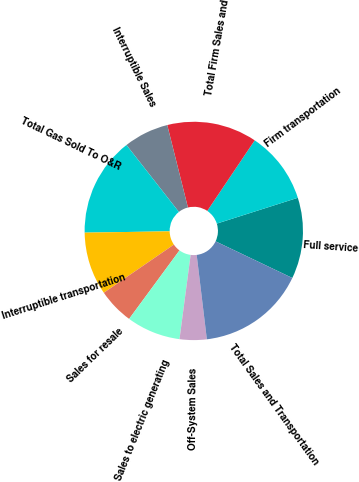<chart> <loc_0><loc_0><loc_500><loc_500><pie_chart><fcel>Full service<fcel>Firm transportation<fcel>Total Firm Sales and<fcel>Interruptible Sales<fcel>Total Gas Sold To O&R<fcel>Interruptible transportation<fcel>Sales for resale<fcel>Sales to electric generating<fcel>Off-System Sales<fcel>Total Sales and Transportation<nl><fcel>12.0%<fcel>10.67%<fcel>13.33%<fcel>6.67%<fcel>14.67%<fcel>9.33%<fcel>5.33%<fcel>8.0%<fcel>4.0%<fcel>16.0%<nl></chart> 